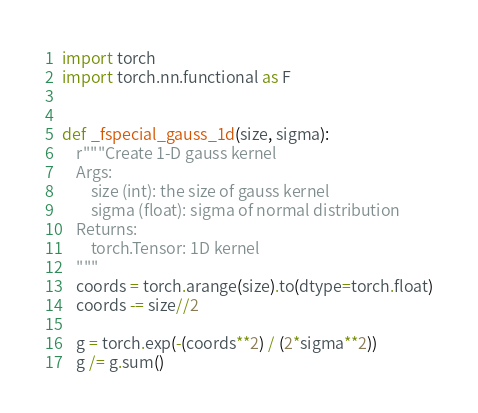<code> <loc_0><loc_0><loc_500><loc_500><_Python_>import torch
import torch.nn.functional as F


def _fspecial_gauss_1d(size, sigma):
    r"""Create 1-D gauss kernel
    Args:
        size (int): the size of gauss kernel
        sigma (float): sigma of normal distribution
    Returns:
        torch.Tensor: 1D kernel
    """
    coords = torch.arange(size).to(dtype=torch.float)
    coords -= size//2

    g = torch.exp(-(coords**2) / (2*sigma**2))
    g /= g.sum()
</code> 